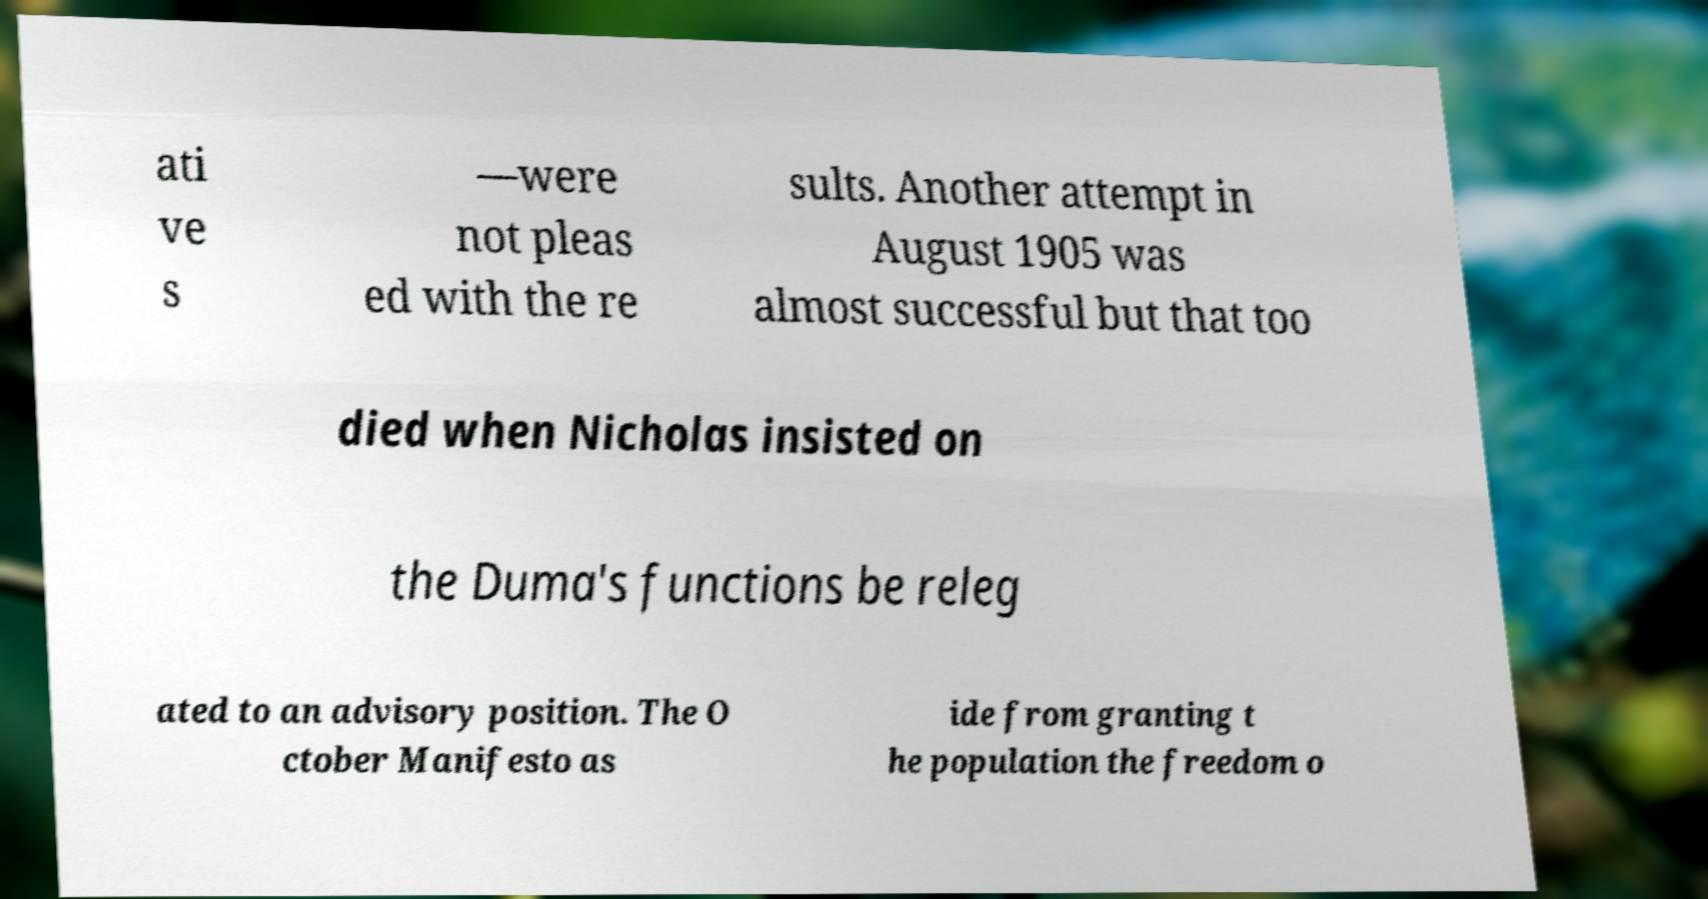Can you read and provide the text displayed in the image?This photo seems to have some interesting text. Can you extract and type it out for me? ati ve s —were not pleas ed with the re sults. Another attempt in August 1905 was almost successful but that too died when Nicholas insisted on the Duma's functions be releg ated to an advisory position. The O ctober Manifesto as ide from granting t he population the freedom o 